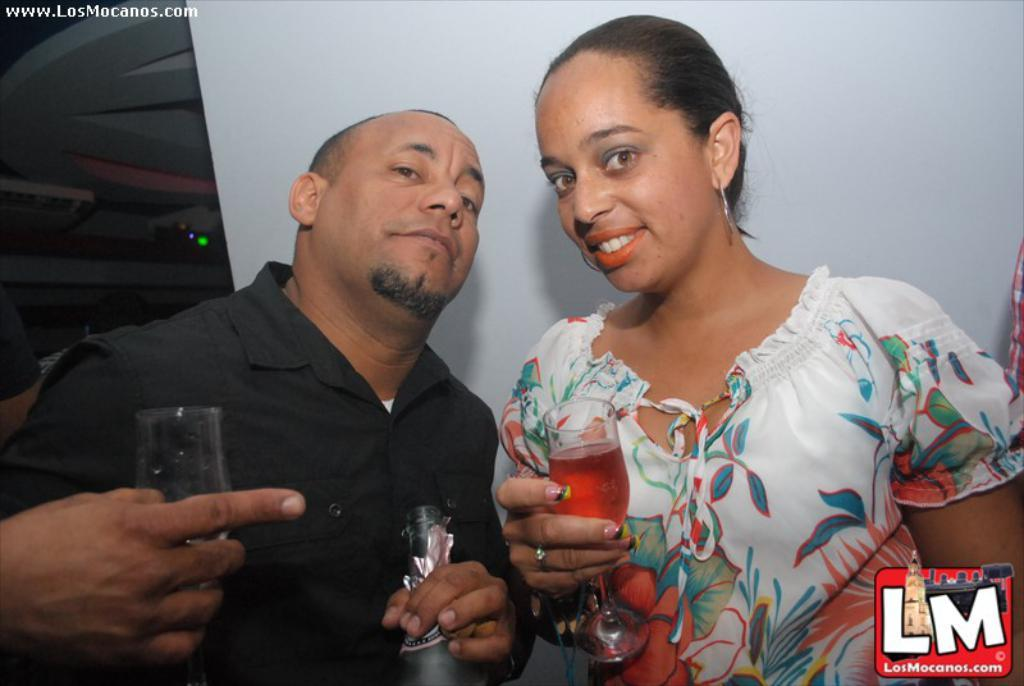What is the lady holding in the image? The lady is holding a glass with a drink in the image. What is the person holding in the image? The person is holding a bottle in the image. Can you describe the hand holding a glass in the image? There is a hand holding a glass in the image. Is there any additional information about the image itself? Yes, there is a watermark on the image. What type of machine can be seen in the background of the image? There is no machine visible in the background of the image. Is there a monkey holding a glass in the image? No, there is no monkey present in the image. 